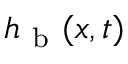<formula> <loc_0><loc_0><loc_500><loc_500>h _ { b } ( x , t )</formula> 